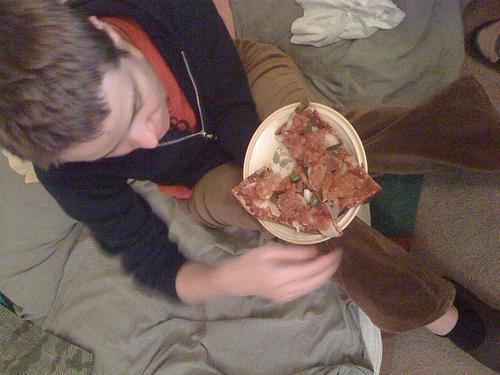How many people are there?
Give a very brief answer. 1. 